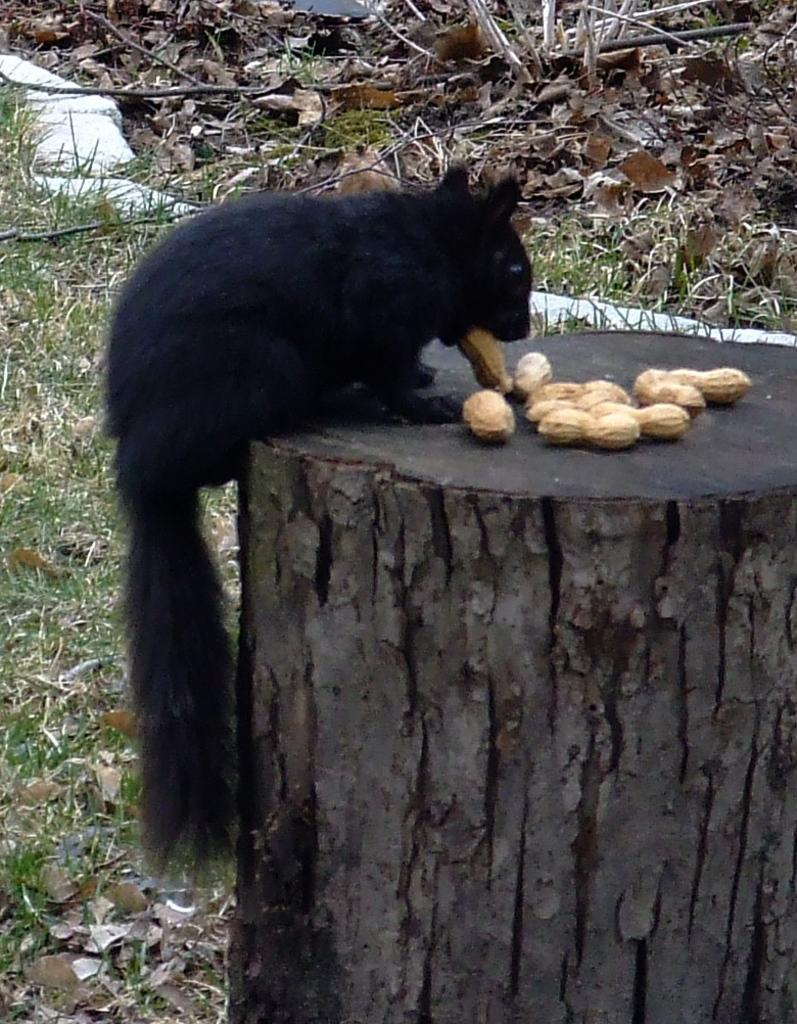What type of animal can be seen in the image? There is a black animal in the image. What is the animal doing in the image? The animal is eating groundnuts. Where is the animal located in the image? The animal is on a wooden log. What type of vegetation is present on the ground in the image? There is grass on the ground in the image. What else can be found on the ground in the image? There are dry leaves on the ground in the image. What type of appliance is being used by the animal in the image? There is no appliance present in the image; the animal is eating groundnuts directly from the ground. Can you provide a list of all the items mentioned in the image? The items mentioned in the image are a black animal, groundnuts, a wooden log, grass, and dry leaves. 